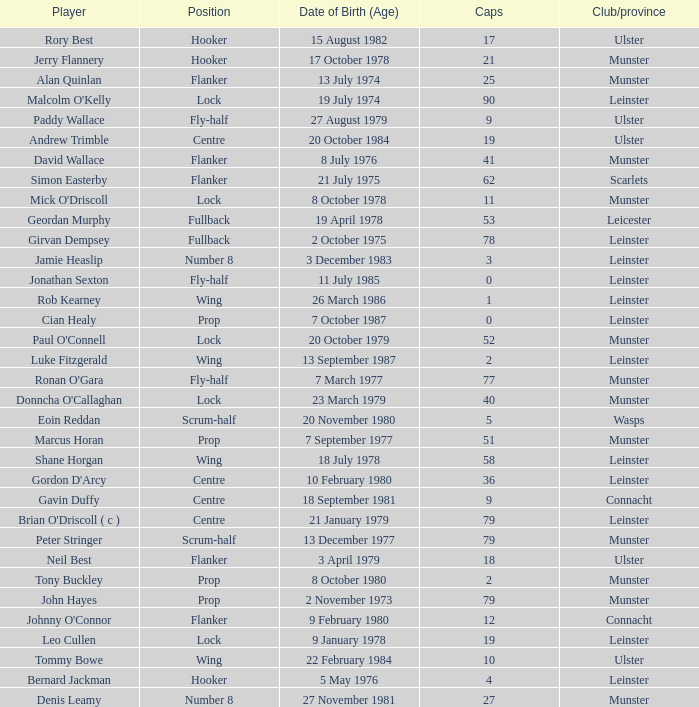What is the total of Caps when player born 13 December 1977? 79.0. 